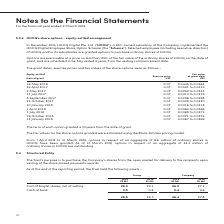According to Singapore Telecommunications's financial document, What model was used to calculate the fair value of the share options granted? Black-Scholes pricing model. The document states: "he share options granted were estimated using the Black-Scholes pricing model...." Also, What can the employees do with the granted options? purchase ordinary shares of HOOQ. The document states: "OQ and/or its subsidiaries are granted options to purchase ordinary shares of HOOQ...." Also, How long does the options take to become fully vested? 4 years from the vesting commencement date. The document states: "te of grant, and are scheduled to be fully vested 4 years from the vesting commencement date. The grant dates, exercise prices and fair values of the ..." Also, On how many different occasions did Singtel grant share options in 2017? Counting the relevant items in the document: 24 April,  2 May,  31 July,  8 September,  23 October, I find 5 instances. The key data points involved are: 2 May, 23 October, 24 April. Also, can you calculate: As at 31 March 2017, options in respect of how many ordinary shares in HOOQ were outstanding?  Based on the calculation: 43.3 - 9.6, the result is 33.7 (in millions). This is based on the information: "March 2019, options in respect of an aggregate of 9.6 million of ordinary shares in HOOQ have been granted. As at 31 March 2019, options in respect of an March 2019, options in respect of an aggregate..." The key data points involved are: 43.3, 9.6. Also, can you calculate: When does the term of the option granted on 31 January 2019 end? Based on the calculation: 31 January 2019 + 10 years, the result is 31 January 2029. This is based on the information: "8 to 0.0373 19 October 2018 0.07 0.0371 to 0.0374 31 January 2019 0.07 0.0367 to 0.0369 The term of each option granted is 10 years from the date of grant...." The key data points involved are: 10 years, 31 January 2019. 